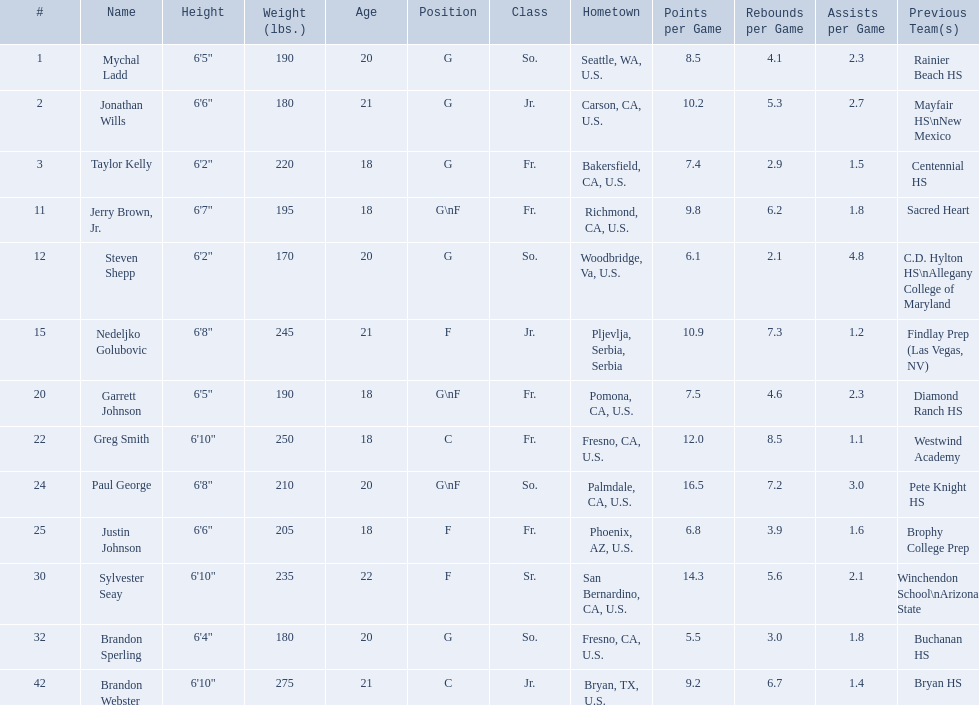What are the names for all players? Mychal Ladd, Jonathan Wills, Taylor Kelly, Jerry Brown, Jr., Steven Shepp, Nedeljko Golubovic, Garrett Johnson, Greg Smith, Paul George, Justin Johnson, Sylvester Seay, Brandon Sperling, Brandon Webster. Which players are taller than 6'8? Nedeljko Golubovic, Greg Smith, Paul George, Sylvester Seay, Brandon Webster. How tall is paul george? 6'8". How tall is greg smith? 6'10". Of these two, which it tallest? Greg Smith. Who are all the players? Mychal Ladd, Jonathan Wills, Taylor Kelly, Jerry Brown, Jr., Steven Shepp, Nedeljko Golubovic, Garrett Johnson, Greg Smith, Paul George, Justin Johnson, Sylvester Seay, Brandon Sperling, Brandon Webster. How tall are they? 6'5", 6'6", 6'2", 6'7", 6'2", 6'8", 6'5", 6'10", 6'8", 6'6", 6'10", 6'4", 6'10". What about just paul george and greg smitih? 6'10", 6'8". And which of the two is taller? Greg Smith. 